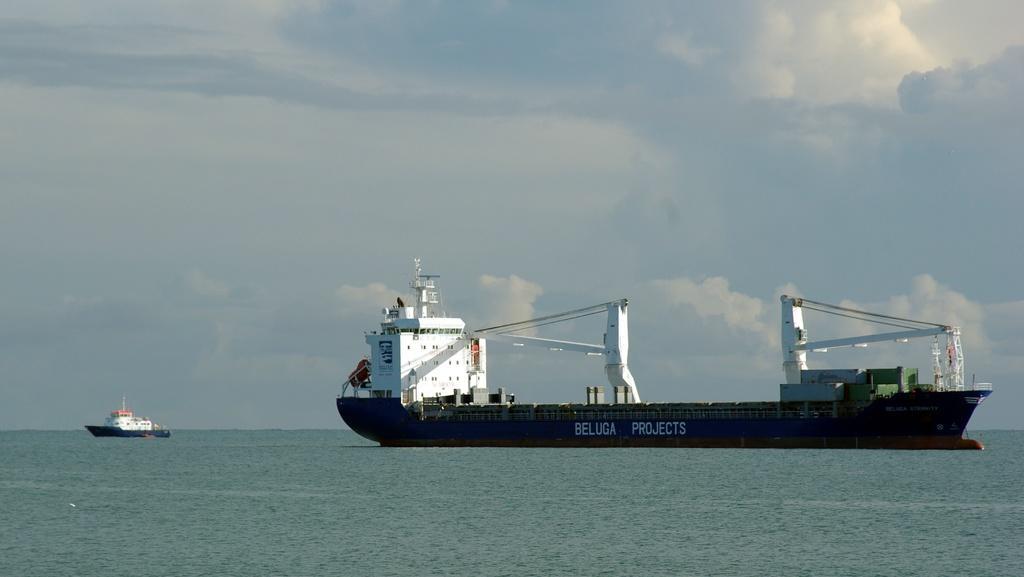Can you describe this image briefly? In this picture, there is an ocean. Towards the right, there is a ship. Before it, there is another small ship. On the top, there is a sky with clouds. 